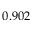<formula> <loc_0><loc_0><loc_500><loc_500>0 . 9 0 2</formula> 